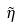<formula> <loc_0><loc_0><loc_500><loc_500>\tilde { \eta }</formula> 